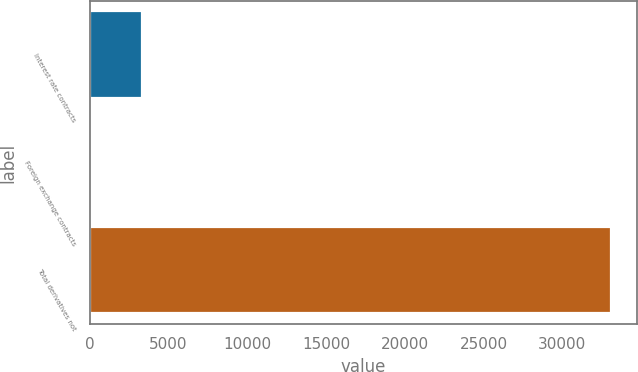<chart> <loc_0><loc_0><loc_500><loc_500><bar_chart><fcel>Interest rate contracts<fcel>Foreign exchange contracts<fcel>Total derivatives not<nl><fcel>3332<fcel>23<fcel>33113<nl></chart> 